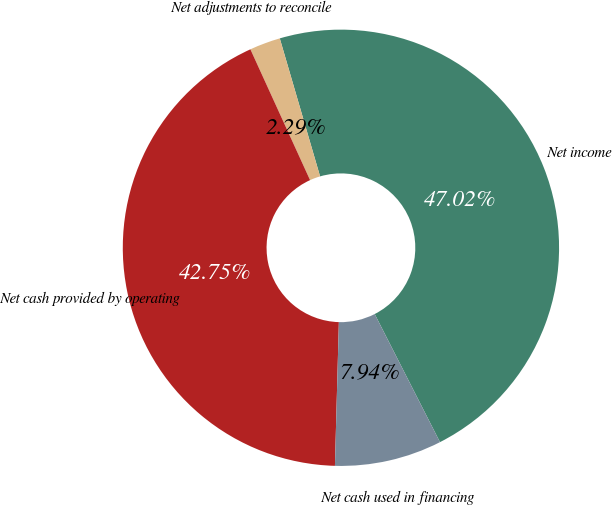Convert chart. <chart><loc_0><loc_0><loc_500><loc_500><pie_chart><fcel>Net income<fcel>Net adjustments to reconcile<fcel>Net cash provided by operating<fcel>Net cash used in financing<nl><fcel>47.02%<fcel>2.29%<fcel>42.75%<fcel>7.94%<nl></chart> 